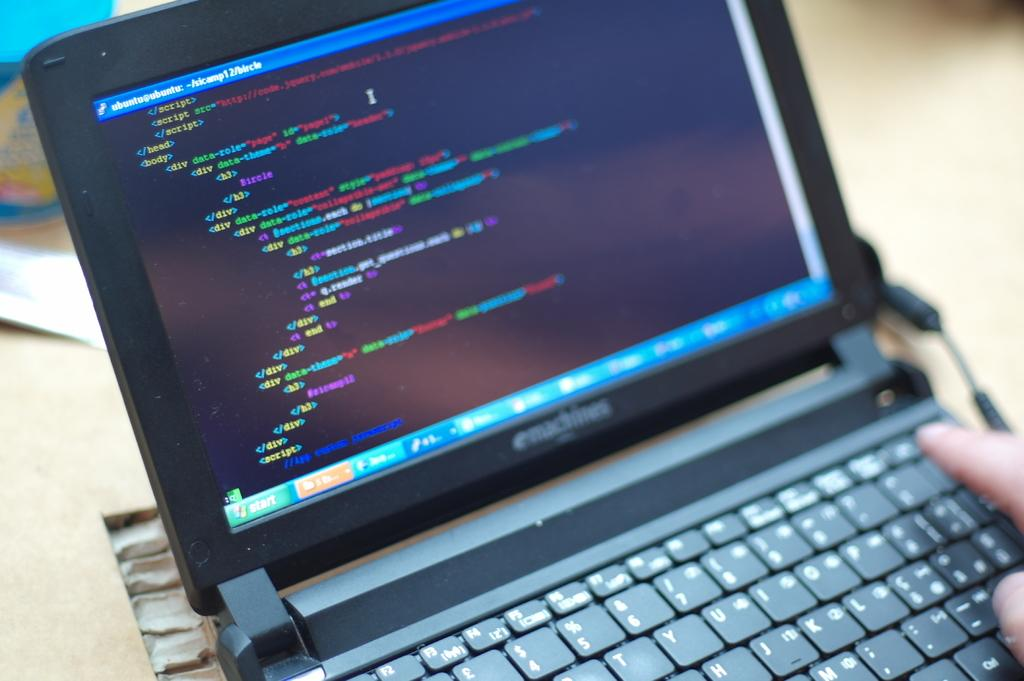<image>
Present a compact description of the photo's key features. An emachines laptop is opened to a black text screen. 